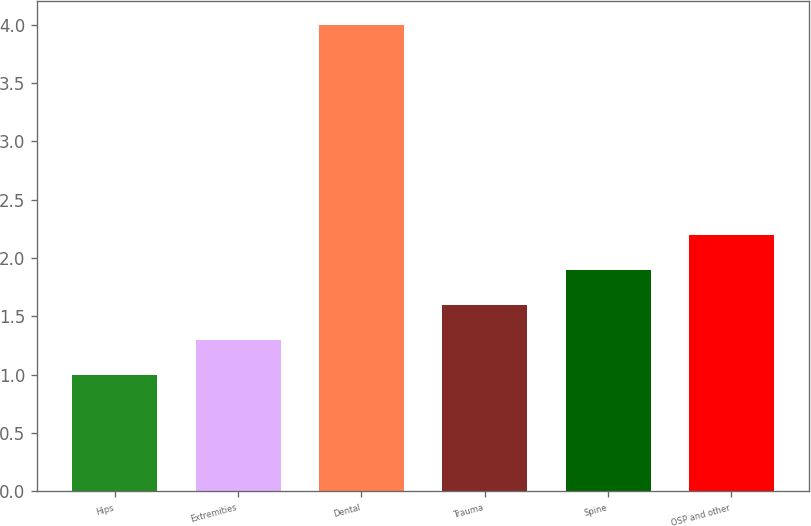Convert chart. <chart><loc_0><loc_0><loc_500><loc_500><bar_chart><fcel>Hips<fcel>Extremities<fcel>Dental<fcel>Trauma<fcel>Spine<fcel>OSP and other<nl><fcel>1<fcel>1.3<fcel>4<fcel>1.6<fcel>1.9<fcel>2.2<nl></chart> 